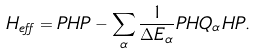<formula> <loc_0><loc_0><loc_500><loc_500>H _ { e f f } = P H P - \sum _ { \alpha } \frac { 1 } { \Delta E _ { \alpha } } P H Q _ { \alpha } H P .</formula> 